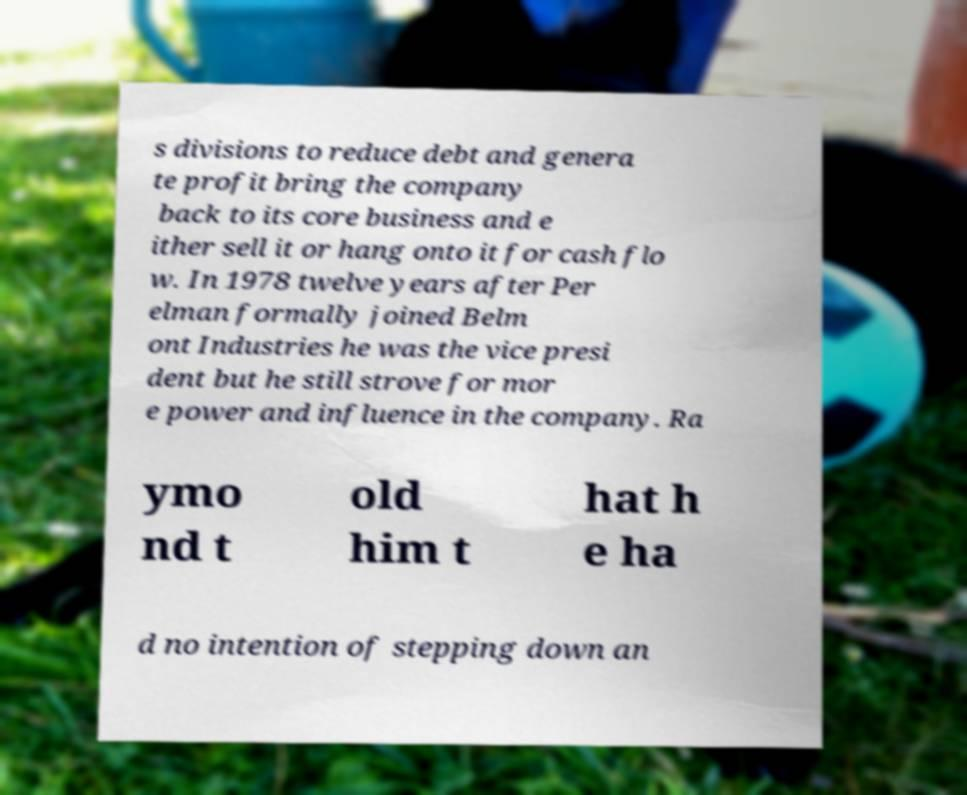Could you assist in decoding the text presented in this image and type it out clearly? s divisions to reduce debt and genera te profit bring the company back to its core business and e ither sell it or hang onto it for cash flo w. In 1978 twelve years after Per elman formally joined Belm ont Industries he was the vice presi dent but he still strove for mor e power and influence in the company. Ra ymo nd t old him t hat h e ha d no intention of stepping down an 